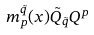<formula> <loc_0><loc_0><loc_500><loc_500>m _ { p } ^ { \tilde { q } } ( x ) \tilde { Q } _ { \tilde { q } } Q ^ { p }</formula> 